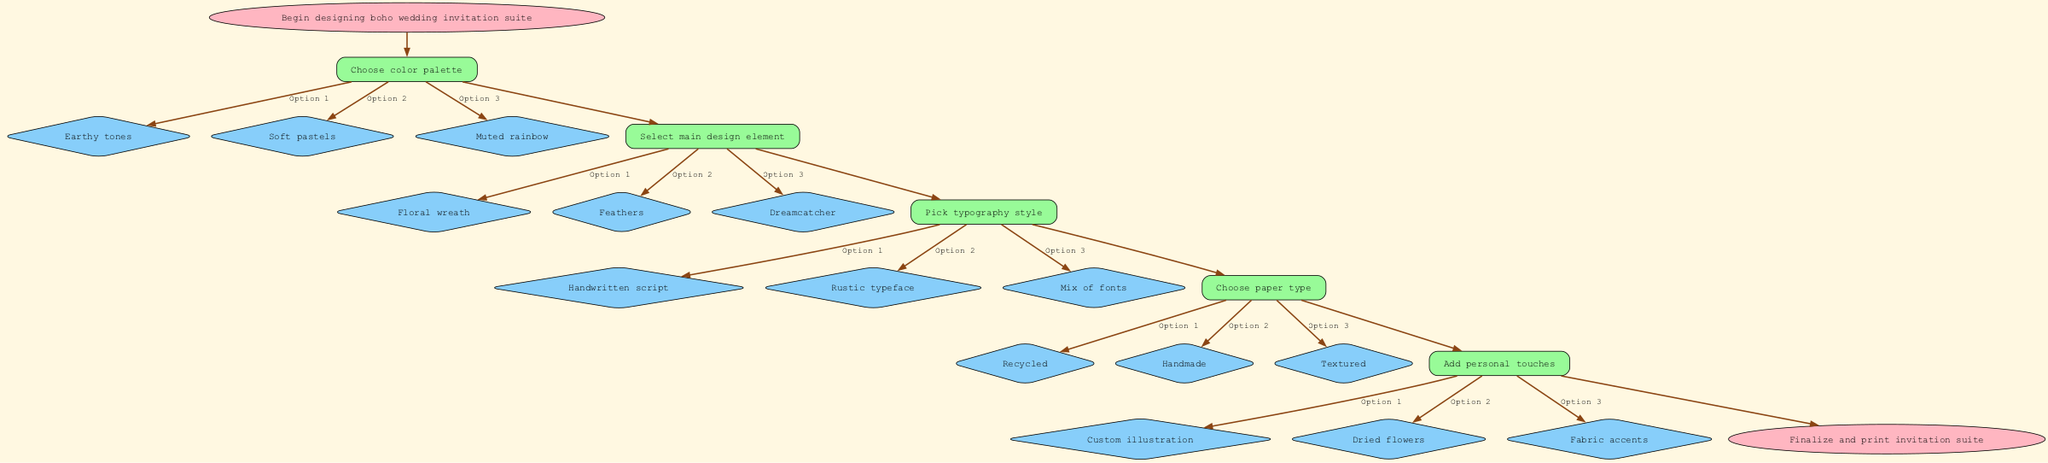What is the first step in designing the boho wedding invitation suite? The first step, represented by the initial node in the diagram, is to "Choose color palette." This is clearly indicated as the starting point of the flowchart.
Answer: Choose color palette How many main design elements are suggested in the diagram? The diagram presents three options for the main design element: "Floral wreath," "Feathers," and "Dreamcatcher." This can be determined by counting the options listed under that particular step.
Answer: 3 What option corresponds to option 2 under the step "Pick typography style"? Under the "Pick typography style" step, option 2 is labeled as "Rustic typeface." This is derived from the options directly listed under that step in the flowchart.
Answer: Rustic typeface What is the last step before finalizing the invitation suite? The last step before concluding the flowchart is "Add personal touches." This identifies what must be done just prior to finalizing and printing the invitation suite.
Answer: Add personal touches If you choose "Soft pastels," which step comes next? After selecting "Soft pastels" in the "Choose color palette" step, the next step, as indicated by the flow, is to "Select main design element." This connection follows the directed path from one step to the other.
Answer: Select main design element How many options are available for paper type? The diagram provides three options for the "Choose paper type" step: "Recycled," "Handmade," and "Textured." By counting these listed options, we arrive at the total.
Answer: 3 Which step follows "Select main design element"? The step that follows "Select main design element" is "Pick typography style." This is determined by looking at the sequence of nodes in the flowchart.
Answer: Pick typography style What is the primary purpose of the flowchart? The primary purpose of the flowchart is to guide the design process for a personalized boho-inspired wedding invitation suite, visualized at the starting point and confirmed at the endpoint.
Answer: Guide design process 